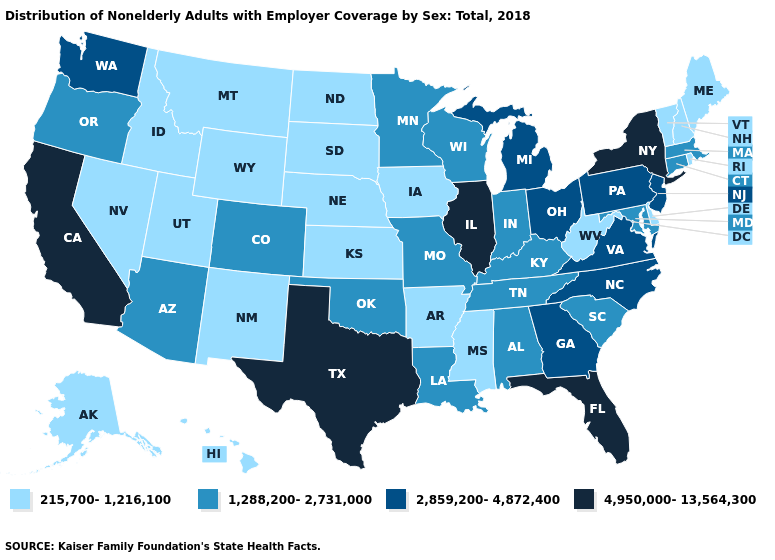What is the value of Georgia?
Keep it brief. 2,859,200-4,872,400. How many symbols are there in the legend?
Keep it brief. 4. Name the states that have a value in the range 215,700-1,216,100?
Short answer required. Alaska, Arkansas, Delaware, Hawaii, Idaho, Iowa, Kansas, Maine, Mississippi, Montana, Nebraska, Nevada, New Hampshire, New Mexico, North Dakota, Rhode Island, South Dakota, Utah, Vermont, West Virginia, Wyoming. What is the value of Kansas?
Short answer required. 215,700-1,216,100. Does the first symbol in the legend represent the smallest category?
Write a very short answer. Yes. What is the value of Maine?
Concise answer only. 215,700-1,216,100. What is the value of New York?
Short answer required. 4,950,000-13,564,300. Does Mississippi have the lowest value in the USA?
Give a very brief answer. Yes. What is the lowest value in states that border Colorado?
Keep it brief. 215,700-1,216,100. What is the value of Massachusetts?
Quick response, please. 1,288,200-2,731,000. Among the states that border New Hampshire , which have the highest value?
Write a very short answer. Massachusetts. Does Idaho have the lowest value in the USA?
Give a very brief answer. Yes. What is the value of Nevada?
Concise answer only. 215,700-1,216,100. What is the value of Georgia?
Write a very short answer. 2,859,200-4,872,400. Name the states that have a value in the range 2,859,200-4,872,400?
Write a very short answer. Georgia, Michigan, New Jersey, North Carolina, Ohio, Pennsylvania, Virginia, Washington. 